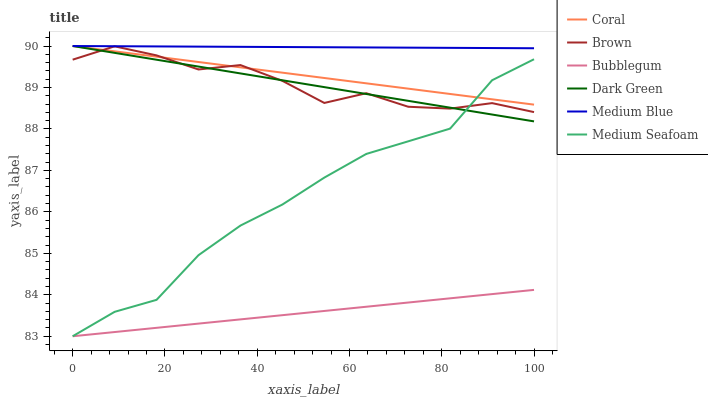Does Bubblegum have the minimum area under the curve?
Answer yes or no. Yes. Does Medium Blue have the maximum area under the curve?
Answer yes or no. Yes. Does Coral have the minimum area under the curve?
Answer yes or no. No. Does Coral have the maximum area under the curve?
Answer yes or no. No. Is Dark Green the smoothest?
Answer yes or no. Yes. Is Brown the roughest?
Answer yes or no. Yes. Is Coral the smoothest?
Answer yes or no. No. Is Coral the roughest?
Answer yes or no. No. Does Bubblegum have the lowest value?
Answer yes or no. Yes. Does Coral have the lowest value?
Answer yes or no. No. Does Dark Green have the highest value?
Answer yes or no. Yes. Does Bubblegum have the highest value?
Answer yes or no. No. Is Bubblegum less than Medium Blue?
Answer yes or no. Yes. Is Brown greater than Bubblegum?
Answer yes or no. Yes. Does Medium Seafoam intersect Brown?
Answer yes or no. Yes. Is Medium Seafoam less than Brown?
Answer yes or no. No. Is Medium Seafoam greater than Brown?
Answer yes or no. No. Does Bubblegum intersect Medium Blue?
Answer yes or no. No. 